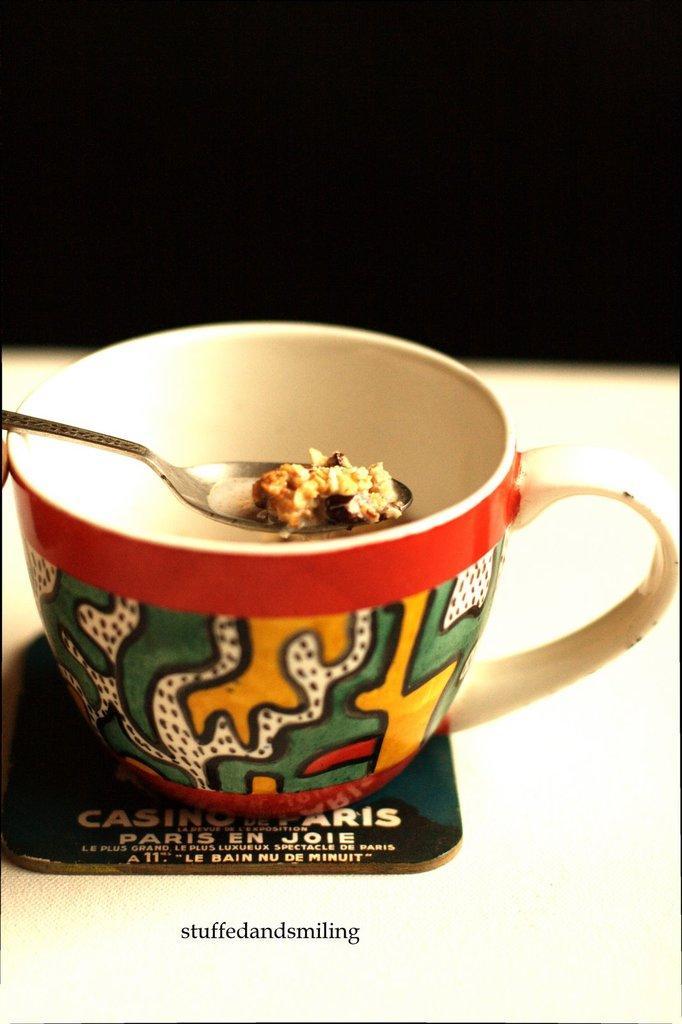Describe this image in one or two sentences. In this image there is a cup and we can see a spoon containing food and a card placed on the table. 